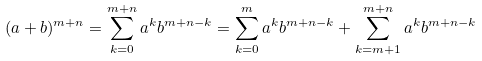Convert formula to latex. <formula><loc_0><loc_0><loc_500><loc_500>( a + b ) ^ { m + n } = \sum _ { k = 0 } ^ { m + n } a ^ { k } b ^ { m + n - k } = \sum _ { k = 0 } ^ { m } a ^ { k } b ^ { m + n - k } + \sum _ { k = m + 1 } ^ { m + n } a ^ { k } b ^ { m + n - k }</formula> 